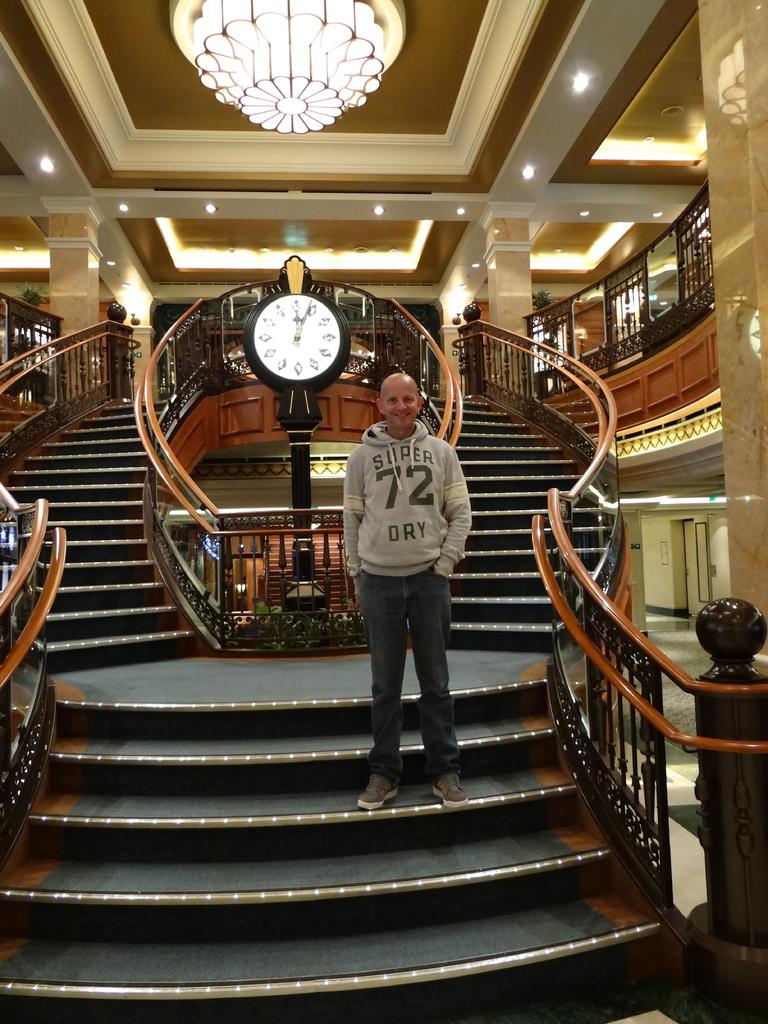What number is on his shirt?
Your response must be concise. 72. What time is displayed on the clock?
Make the answer very short. 12:05. 